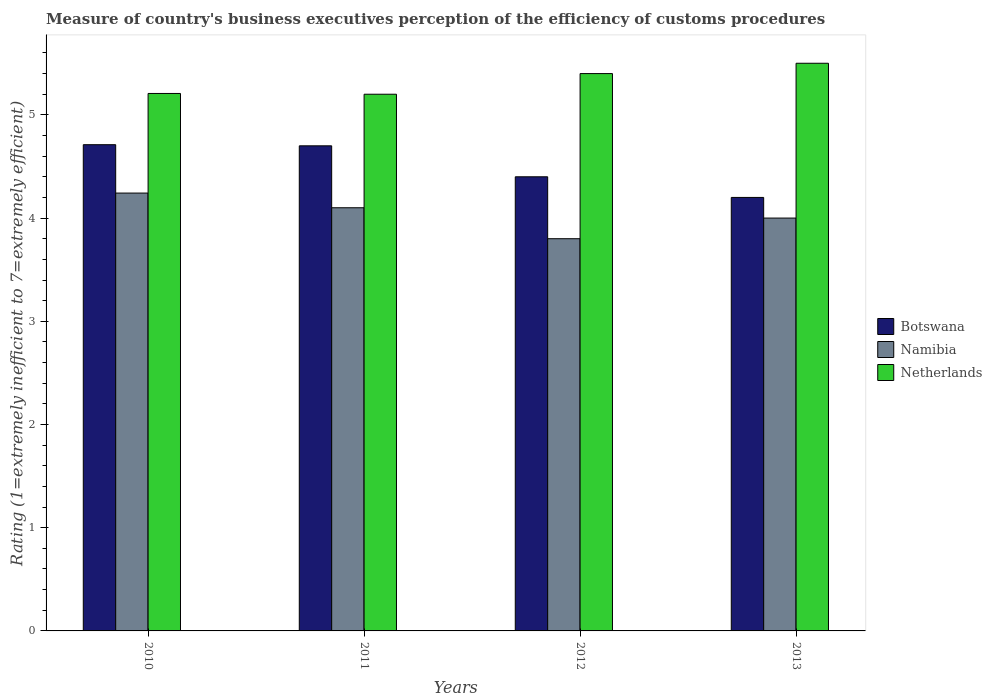How many different coloured bars are there?
Ensure brevity in your answer.  3. How many groups of bars are there?
Your answer should be compact. 4. Are the number of bars per tick equal to the number of legend labels?
Ensure brevity in your answer.  Yes. Are the number of bars on each tick of the X-axis equal?
Provide a short and direct response. Yes. How many bars are there on the 4th tick from the left?
Your answer should be very brief. 3. In how many cases, is the number of bars for a given year not equal to the number of legend labels?
Your response must be concise. 0. What is the rating of the efficiency of customs procedure in Namibia in 2010?
Your answer should be compact. 4.24. Across all years, what is the maximum rating of the efficiency of customs procedure in Botswana?
Your answer should be compact. 4.71. What is the total rating of the efficiency of customs procedure in Namibia in the graph?
Your answer should be very brief. 16.14. What is the difference between the rating of the efficiency of customs procedure in Netherlands in 2010 and that in 2013?
Offer a terse response. -0.29. What is the difference between the rating of the efficiency of customs procedure in Netherlands in 2011 and the rating of the efficiency of customs procedure in Namibia in 2013?
Ensure brevity in your answer.  1.2. What is the average rating of the efficiency of customs procedure in Botswana per year?
Your response must be concise. 4.5. In the year 2013, what is the difference between the rating of the efficiency of customs procedure in Botswana and rating of the efficiency of customs procedure in Namibia?
Your answer should be compact. 0.2. What is the ratio of the rating of the efficiency of customs procedure in Namibia in 2010 to that in 2012?
Provide a succinct answer. 1.12. Is the rating of the efficiency of customs procedure in Namibia in 2010 less than that in 2012?
Ensure brevity in your answer.  No. What is the difference between the highest and the second highest rating of the efficiency of customs procedure in Namibia?
Ensure brevity in your answer.  0.14. What is the difference between the highest and the lowest rating of the efficiency of customs procedure in Netherlands?
Provide a succinct answer. 0.3. In how many years, is the rating of the efficiency of customs procedure in Netherlands greater than the average rating of the efficiency of customs procedure in Netherlands taken over all years?
Make the answer very short. 2. What does the 2nd bar from the left in 2011 represents?
Offer a terse response. Namibia. What does the 2nd bar from the right in 2011 represents?
Ensure brevity in your answer.  Namibia. Is it the case that in every year, the sum of the rating of the efficiency of customs procedure in Botswana and rating of the efficiency of customs procedure in Netherlands is greater than the rating of the efficiency of customs procedure in Namibia?
Your answer should be very brief. Yes. How many bars are there?
Offer a terse response. 12. Are all the bars in the graph horizontal?
Offer a very short reply. No. What is the difference between two consecutive major ticks on the Y-axis?
Make the answer very short. 1. What is the title of the graph?
Ensure brevity in your answer.  Measure of country's business executives perception of the efficiency of customs procedures. What is the label or title of the Y-axis?
Offer a very short reply. Rating (1=extremely inefficient to 7=extremely efficient). What is the Rating (1=extremely inefficient to 7=extremely efficient) of Botswana in 2010?
Your response must be concise. 4.71. What is the Rating (1=extremely inefficient to 7=extremely efficient) in Namibia in 2010?
Ensure brevity in your answer.  4.24. What is the Rating (1=extremely inefficient to 7=extremely efficient) of Netherlands in 2010?
Ensure brevity in your answer.  5.21. What is the Rating (1=extremely inefficient to 7=extremely efficient) in Netherlands in 2011?
Your answer should be very brief. 5.2. What is the Rating (1=extremely inefficient to 7=extremely efficient) in Namibia in 2013?
Give a very brief answer. 4. What is the Rating (1=extremely inefficient to 7=extremely efficient) in Netherlands in 2013?
Keep it short and to the point. 5.5. Across all years, what is the maximum Rating (1=extremely inefficient to 7=extremely efficient) in Botswana?
Give a very brief answer. 4.71. Across all years, what is the maximum Rating (1=extremely inefficient to 7=extremely efficient) in Namibia?
Ensure brevity in your answer.  4.24. Across all years, what is the maximum Rating (1=extremely inefficient to 7=extremely efficient) of Netherlands?
Provide a succinct answer. 5.5. Across all years, what is the minimum Rating (1=extremely inefficient to 7=extremely efficient) in Netherlands?
Your response must be concise. 5.2. What is the total Rating (1=extremely inefficient to 7=extremely efficient) of Botswana in the graph?
Your response must be concise. 18.01. What is the total Rating (1=extremely inefficient to 7=extremely efficient) in Namibia in the graph?
Your answer should be very brief. 16.14. What is the total Rating (1=extremely inefficient to 7=extremely efficient) of Netherlands in the graph?
Your answer should be very brief. 21.31. What is the difference between the Rating (1=extremely inefficient to 7=extremely efficient) in Botswana in 2010 and that in 2011?
Offer a terse response. 0.01. What is the difference between the Rating (1=extremely inefficient to 7=extremely efficient) in Namibia in 2010 and that in 2011?
Your answer should be compact. 0.14. What is the difference between the Rating (1=extremely inefficient to 7=extremely efficient) in Netherlands in 2010 and that in 2011?
Make the answer very short. 0.01. What is the difference between the Rating (1=extremely inefficient to 7=extremely efficient) of Botswana in 2010 and that in 2012?
Make the answer very short. 0.31. What is the difference between the Rating (1=extremely inefficient to 7=extremely efficient) of Namibia in 2010 and that in 2012?
Make the answer very short. 0.44. What is the difference between the Rating (1=extremely inefficient to 7=extremely efficient) in Netherlands in 2010 and that in 2012?
Your answer should be compact. -0.19. What is the difference between the Rating (1=extremely inefficient to 7=extremely efficient) in Botswana in 2010 and that in 2013?
Give a very brief answer. 0.51. What is the difference between the Rating (1=extremely inefficient to 7=extremely efficient) in Namibia in 2010 and that in 2013?
Offer a terse response. 0.24. What is the difference between the Rating (1=extremely inefficient to 7=extremely efficient) of Netherlands in 2010 and that in 2013?
Provide a succinct answer. -0.29. What is the difference between the Rating (1=extremely inefficient to 7=extremely efficient) in Netherlands in 2011 and that in 2013?
Ensure brevity in your answer.  -0.3. What is the difference between the Rating (1=extremely inefficient to 7=extremely efficient) in Botswana in 2012 and that in 2013?
Offer a very short reply. 0.2. What is the difference between the Rating (1=extremely inefficient to 7=extremely efficient) in Netherlands in 2012 and that in 2013?
Your response must be concise. -0.1. What is the difference between the Rating (1=extremely inefficient to 7=extremely efficient) in Botswana in 2010 and the Rating (1=extremely inefficient to 7=extremely efficient) in Namibia in 2011?
Make the answer very short. 0.61. What is the difference between the Rating (1=extremely inefficient to 7=extremely efficient) of Botswana in 2010 and the Rating (1=extremely inefficient to 7=extremely efficient) of Netherlands in 2011?
Provide a short and direct response. -0.49. What is the difference between the Rating (1=extremely inefficient to 7=extremely efficient) in Namibia in 2010 and the Rating (1=extremely inefficient to 7=extremely efficient) in Netherlands in 2011?
Ensure brevity in your answer.  -0.96. What is the difference between the Rating (1=extremely inefficient to 7=extremely efficient) of Botswana in 2010 and the Rating (1=extremely inefficient to 7=extremely efficient) of Namibia in 2012?
Your response must be concise. 0.91. What is the difference between the Rating (1=extremely inefficient to 7=extremely efficient) in Botswana in 2010 and the Rating (1=extremely inefficient to 7=extremely efficient) in Netherlands in 2012?
Offer a very short reply. -0.69. What is the difference between the Rating (1=extremely inefficient to 7=extremely efficient) in Namibia in 2010 and the Rating (1=extremely inefficient to 7=extremely efficient) in Netherlands in 2012?
Your answer should be compact. -1.16. What is the difference between the Rating (1=extremely inefficient to 7=extremely efficient) of Botswana in 2010 and the Rating (1=extremely inefficient to 7=extremely efficient) of Namibia in 2013?
Give a very brief answer. 0.71. What is the difference between the Rating (1=extremely inefficient to 7=extremely efficient) in Botswana in 2010 and the Rating (1=extremely inefficient to 7=extremely efficient) in Netherlands in 2013?
Your answer should be compact. -0.79. What is the difference between the Rating (1=extremely inefficient to 7=extremely efficient) in Namibia in 2010 and the Rating (1=extremely inefficient to 7=extremely efficient) in Netherlands in 2013?
Provide a short and direct response. -1.26. What is the difference between the Rating (1=extremely inefficient to 7=extremely efficient) in Botswana in 2011 and the Rating (1=extremely inefficient to 7=extremely efficient) in Netherlands in 2012?
Your response must be concise. -0.7. What is the difference between the Rating (1=extremely inefficient to 7=extremely efficient) in Botswana in 2012 and the Rating (1=extremely inefficient to 7=extremely efficient) in Namibia in 2013?
Give a very brief answer. 0.4. What is the difference between the Rating (1=extremely inefficient to 7=extremely efficient) in Botswana in 2012 and the Rating (1=extremely inefficient to 7=extremely efficient) in Netherlands in 2013?
Keep it short and to the point. -1.1. What is the difference between the Rating (1=extremely inefficient to 7=extremely efficient) of Namibia in 2012 and the Rating (1=extremely inefficient to 7=extremely efficient) of Netherlands in 2013?
Your response must be concise. -1.7. What is the average Rating (1=extremely inefficient to 7=extremely efficient) of Botswana per year?
Keep it short and to the point. 4.5. What is the average Rating (1=extremely inefficient to 7=extremely efficient) of Namibia per year?
Ensure brevity in your answer.  4.04. What is the average Rating (1=extremely inefficient to 7=extremely efficient) in Netherlands per year?
Offer a terse response. 5.33. In the year 2010, what is the difference between the Rating (1=extremely inefficient to 7=extremely efficient) in Botswana and Rating (1=extremely inefficient to 7=extremely efficient) in Namibia?
Give a very brief answer. 0.47. In the year 2010, what is the difference between the Rating (1=extremely inefficient to 7=extremely efficient) of Botswana and Rating (1=extremely inefficient to 7=extremely efficient) of Netherlands?
Your answer should be compact. -0.5. In the year 2010, what is the difference between the Rating (1=extremely inefficient to 7=extremely efficient) in Namibia and Rating (1=extremely inefficient to 7=extremely efficient) in Netherlands?
Keep it short and to the point. -0.97. In the year 2011, what is the difference between the Rating (1=extremely inefficient to 7=extremely efficient) in Botswana and Rating (1=extremely inefficient to 7=extremely efficient) in Namibia?
Provide a succinct answer. 0.6. In the year 2012, what is the difference between the Rating (1=extremely inefficient to 7=extremely efficient) of Botswana and Rating (1=extremely inefficient to 7=extremely efficient) of Namibia?
Give a very brief answer. 0.6. In the year 2013, what is the difference between the Rating (1=extremely inefficient to 7=extremely efficient) of Namibia and Rating (1=extremely inefficient to 7=extremely efficient) of Netherlands?
Keep it short and to the point. -1.5. What is the ratio of the Rating (1=extremely inefficient to 7=extremely efficient) in Namibia in 2010 to that in 2011?
Your answer should be compact. 1.03. What is the ratio of the Rating (1=extremely inefficient to 7=extremely efficient) of Botswana in 2010 to that in 2012?
Your response must be concise. 1.07. What is the ratio of the Rating (1=extremely inefficient to 7=extremely efficient) of Namibia in 2010 to that in 2012?
Provide a succinct answer. 1.12. What is the ratio of the Rating (1=extremely inefficient to 7=extremely efficient) in Netherlands in 2010 to that in 2012?
Offer a terse response. 0.96. What is the ratio of the Rating (1=extremely inefficient to 7=extremely efficient) of Botswana in 2010 to that in 2013?
Make the answer very short. 1.12. What is the ratio of the Rating (1=extremely inefficient to 7=extremely efficient) in Namibia in 2010 to that in 2013?
Provide a succinct answer. 1.06. What is the ratio of the Rating (1=extremely inefficient to 7=extremely efficient) in Netherlands in 2010 to that in 2013?
Provide a succinct answer. 0.95. What is the ratio of the Rating (1=extremely inefficient to 7=extremely efficient) in Botswana in 2011 to that in 2012?
Ensure brevity in your answer.  1.07. What is the ratio of the Rating (1=extremely inefficient to 7=extremely efficient) in Namibia in 2011 to that in 2012?
Offer a very short reply. 1.08. What is the ratio of the Rating (1=extremely inefficient to 7=extremely efficient) in Botswana in 2011 to that in 2013?
Keep it short and to the point. 1.12. What is the ratio of the Rating (1=extremely inefficient to 7=extremely efficient) of Netherlands in 2011 to that in 2013?
Provide a short and direct response. 0.95. What is the ratio of the Rating (1=extremely inefficient to 7=extremely efficient) of Botswana in 2012 to that in 2013?
Make the answer very short. 1.05. What is the ratio of the Rating (1=extremely inefficient to 7=extremely efficient) of Namibia in 2012 to that in 2013?
Offer a very short reply. 0.95. What is the ratio of the Rating (1=extremely inefficient to 7=extremely efficient) in Netherlands in 2012 to that in 2013?
Your answer should be very brief. 0.98. What is the difference between the highest and the second highest Rating (1=extremely inefficient to 7=extremely efficient) of Botswana?
Your answer should be very brief. 0.01. What is the difference between the highest and the second highest Rating (1=extremely inefficient to 7=extremely efficient) of Namibia?
Keep it short and to the point. 0.14. What is the difference between the highest and the lowest Rating (1=extremely inefficient to 7=extremely efficient) of Botswana?
Offer a very short reply. 0.51. What is the difference between the highest and the lowest Rating (1=extremely inefficient to 7=extremely efficient) of Namibia?
Your answer should be very brief. 0.44. What is the difference between the highest and the lowest Rating (1=extremely inefficient to 7=extremely efficient) in Netherlands?
Provide a succinct answer. 0.3. 